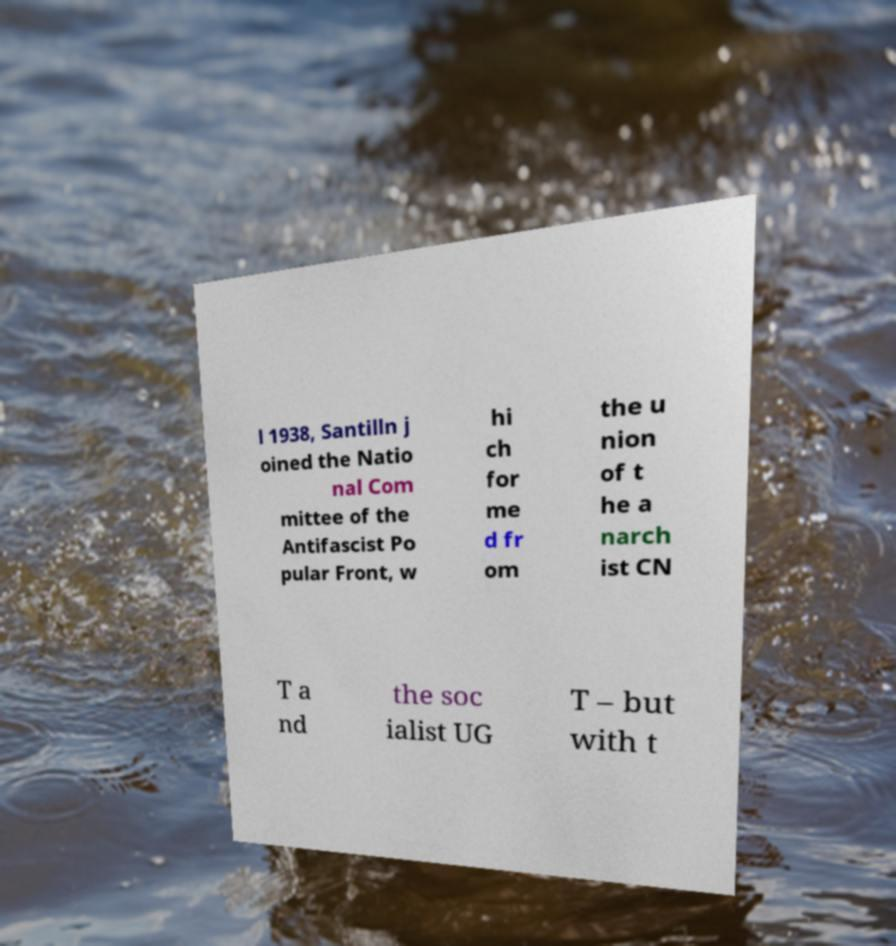Can you read and provide the text displayed in the image?This photo seems to have some interesting text. Can you extract and type it out for me? l 1938, Santilln j oined the Natio nal Com mittee of the Antifascist Po pular Front, w hi ch for me d fr om the u nion of t he a narch ist CN T a nd the soc ialist UG T – but with t 